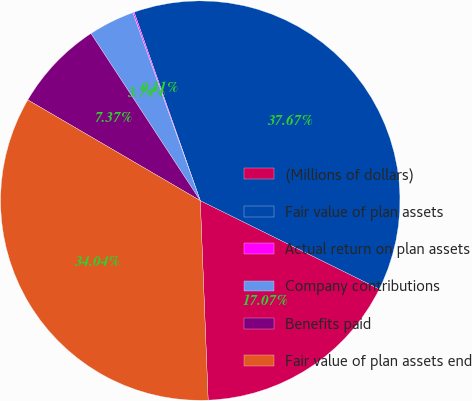Convert chart. <chart><loc_0><loc_0><loc_500><loc_500><pie_chart><fcel>(Millions of dollars)<fcel>Fair value of plan assets<fcel>Actual return on plan assets<fcel>Company contributions<fcel>Benefits paid<fcel>Fair value of plan assets end<nl><fcel>17.07%<fcel>37.67%<fcel>0.11%<fcel>3.74%<fcel>7.37%<fcel>34.04%<nl></chart> 